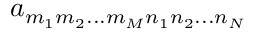Convert formula to latex. <formula><loc_0><loc_0><loc_500><loc_500>a _ { m _ { 1 } m _ { 2 } \dots m _ { M } n _ { 1 } n _ { 2 } \dots n _ { N } }</formula> 